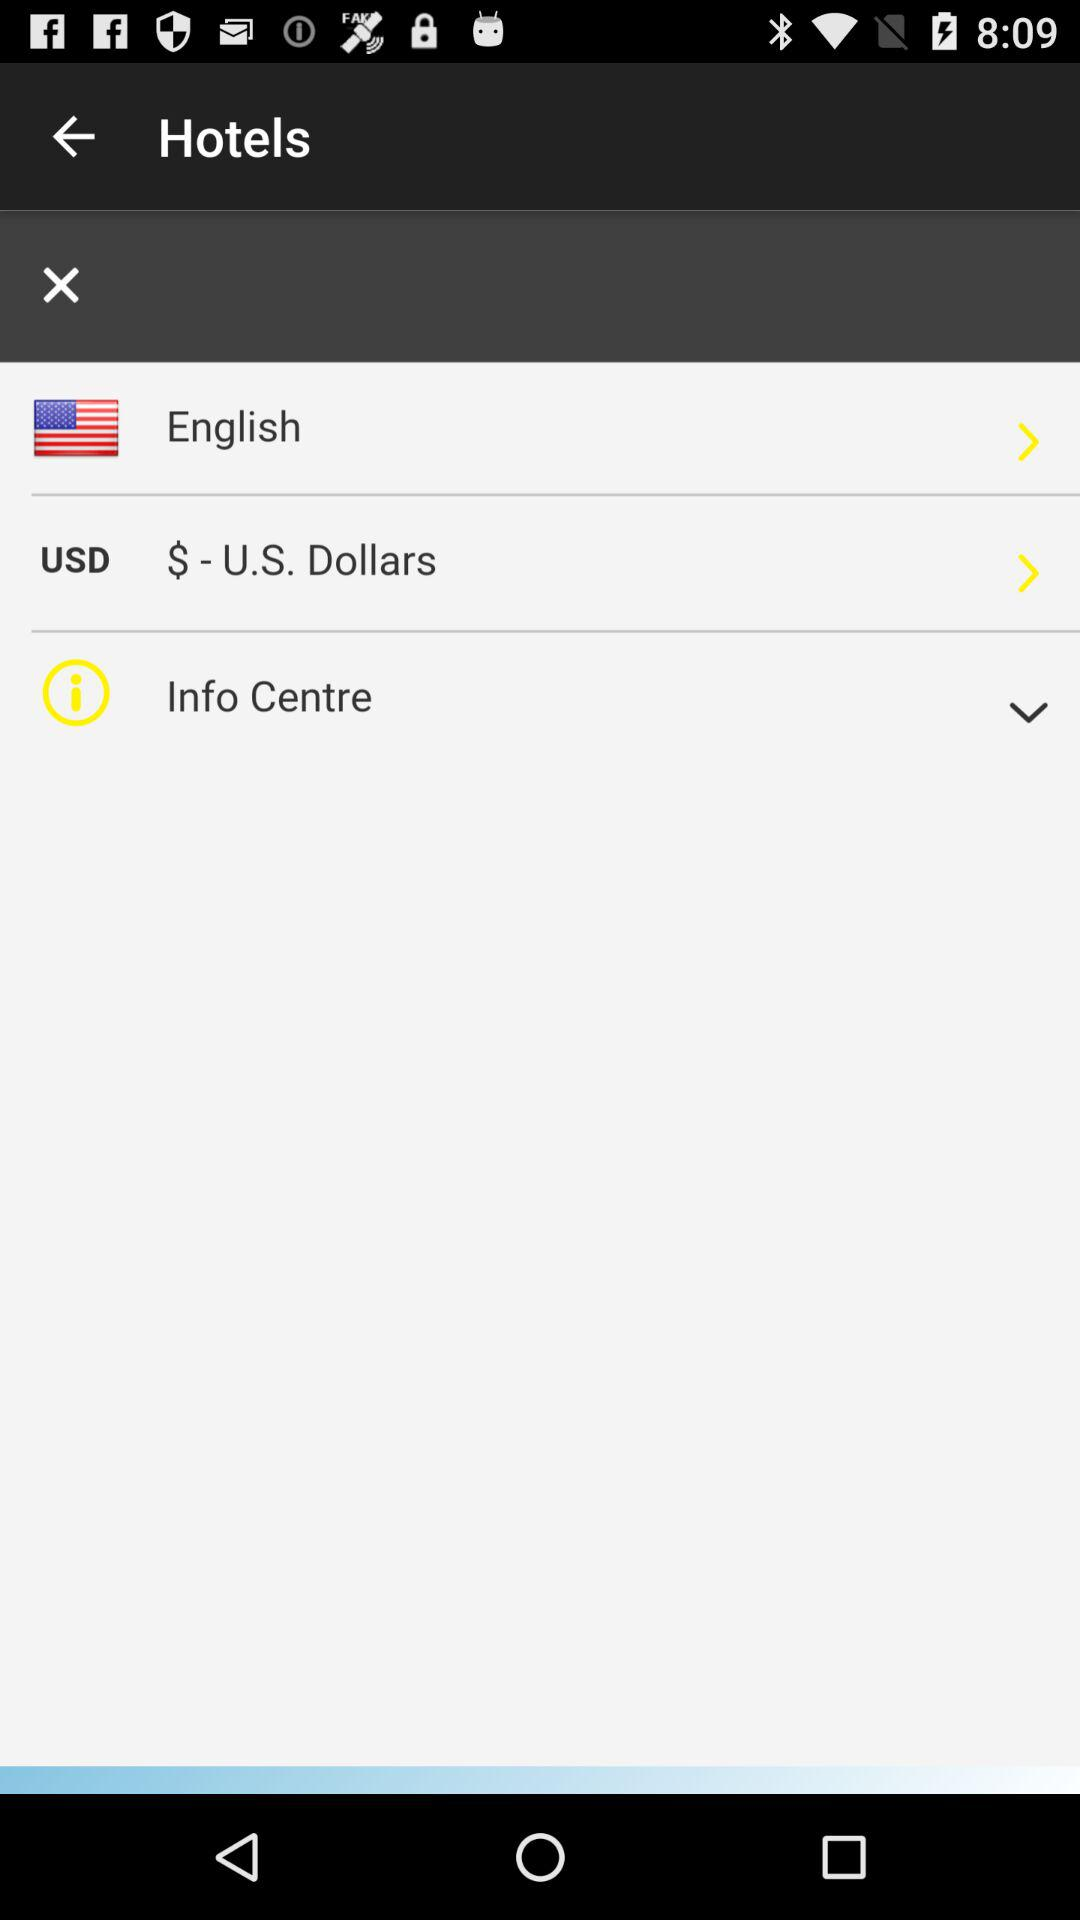Which is the language? The language is English. 